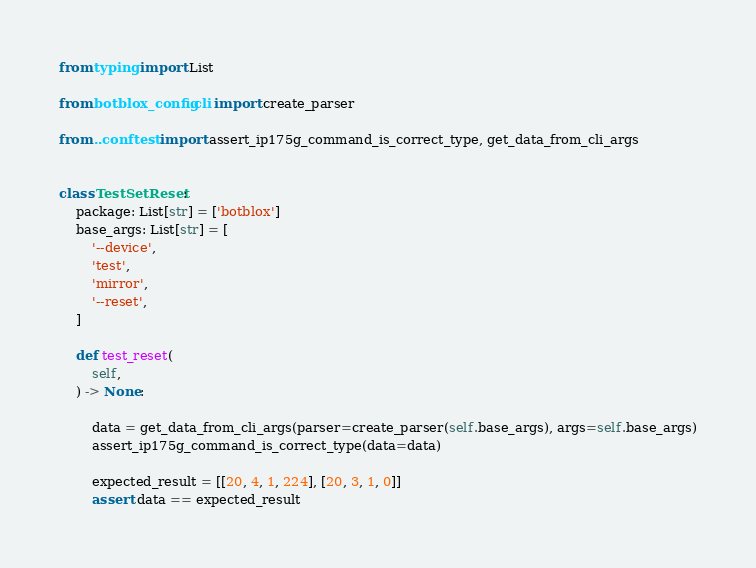Convert code to text. <code><loc_0><loc_0><loc_500><loc_500><_Python_>from typing import List

from botblox_config.cli import create_parser

from ..conftest import assert_ip175g_command_is_correct_type, get_data_from_cli_args


class TestSetReset:
    package: List[str] = ['botblox']
    base_args: List[str] = [
        '--device',
        'test',
        'mirror',
        '--reset',
    ]

    def test_reset(
        self,
    ) -> None:

        data = get_data_from_cli_args(parser=create_parser(self.base_args), args=self.base_args)
        assert_ip175g_command_is_correct_type(data=data)

        expected_result = [[20, 4, 1, 224], [20, 3, 1, 0]]
        assert data == expected_result
</code> 